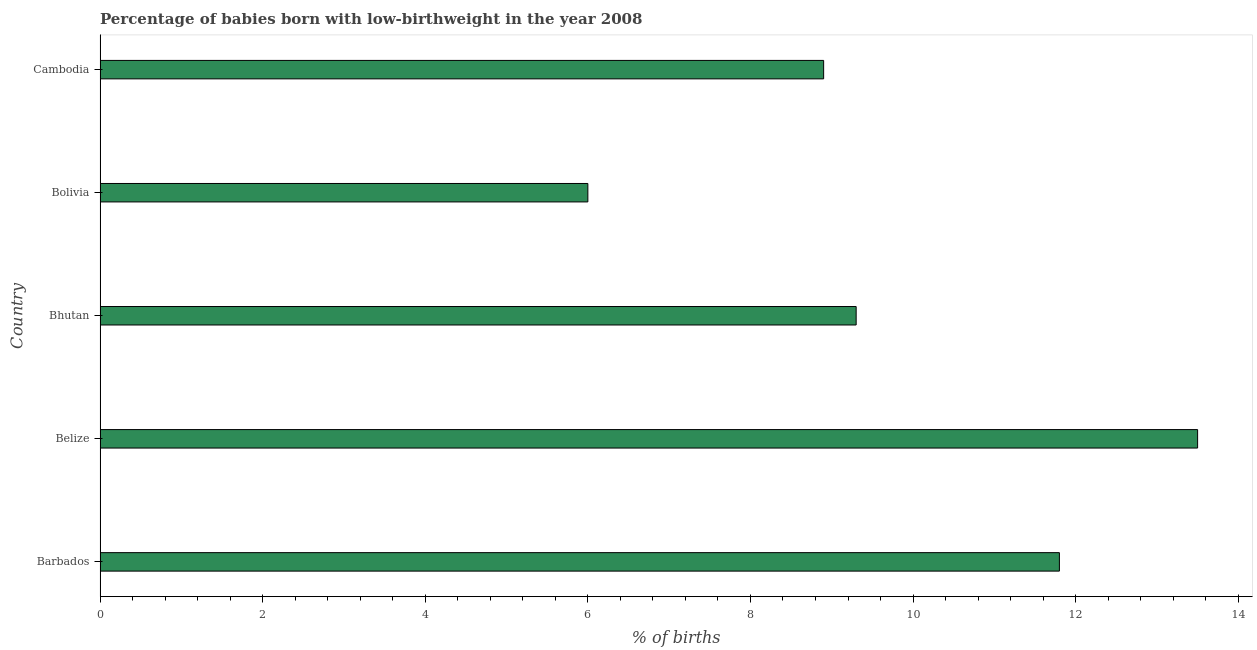Does the graph contain any zero values?
Offer a terse response. No. Does the graph contain grids?
Make the answer very short. No. What is the title of the graph?
Provide a short and direct response. Percentage of babies born with low-birthweight in the year 2008. What is the label or title of the X-axis?
Your answer should be compact. % of births. What is the label or title of the Y-axis?
Ensure brevity in your answer.  Country. What is the percentage of babies who were born with low-birthweight in Bolivia?
Make the answer very short. 6. Across all countries, what is the maximum percentage of babies who were born with low-birthweight?
Your answer should be compact. 13.5. Across all countries, what is the minimum percentage of babies who were born with low-birthweight?
Your response must be concise. 6. In which country was the percentage of babies who were born with low-birthweight maximum?
Provide a succinct answer. Belize. In which country was the percentage of babies who were born with low-birthweight minimum?
Your response must be concise. Bolivia. What is the sum of the percentage of babies who were born with low-birthweight?
Keep it short and to the point. 49.5. What is the average percentage of babies who were born with low-birthweight per country?
Ensure brevity in your answer.  9.9. What is the ratio of the percentage of babies who were born with low-birthweight in Barbados to that in Bhutan?
Offer a terse response. 1.27. Is the difference between the percentage of babies who were born with low-birthweight in Barbados and Belize greater than the difference between any two countries?
Make the answer very short. No. In how many countries, is the percentage of babies who were born with low-birthweight greater than the average percentage of babies who were born with low-birthweight taken over all countries?
Provide a succinct answer. 2. How many countries are there in the graph?
Your answer should be very brief. 5. Are the values on the major ticks of X-axis written in scientific E-notation?
Give a very brief answer. No. What is the % of births of Barbados?
Give a very brief answer. 11.8. What is the % of births in Belize?
Your answer should be very brief. 13.5. What is the difference between the % of births in Barbados and Belize?
Give a very brief answer. -1.7. What is the difference between the % of births in Barbados and Bhutan?
Give a very brief answer. 2.5. What is the difference between the % of births in Barbados and Bolivia?
Ensure brevity in your answer.  5.8. What is the difference between the % of births in Belize and Bhutan?
Your answer should be very brief. 4.2. What is the difference between the % of births in Belize and Bolivia?
Make the answer very short. 7.5. What is the difference between the % of births in Bhutan and Bolivia?
Offer a very short reply. 3.3. What is the difference between the % of births in Bolivia and Cambodia?
Your answer should be compact. -2.9. What is the ratio of the % of births in Barbados to that in Belize?
Give a very brief answer. 0.87. What is the ratio of the % of births in Barbados to that in Bhutan?
Give a very brief answer. 1.27. What is the ratio of the % of births in Barbados to that in Bolivia?
Make the answer very short. 1.97. What is the ratio of the % of births in Barbados to that in Cambodia?
Offer a very short reply. 1.33. What is the ratio of the % of births in Belize to that in Bhutan?
Your answer should be very brief. 1.45. What is the ratio of the % of births in Belize to that in Bolivia?
Keep it short and to the point. 2.25. What is the ratio of the % of births in Belize to that in Cambodia?
Make the answer very short. 1.52. What is the ratio of the % of births in Bhutan to that in Bolivia?
Offer a terse response. 1.55. What is the ratio of the % of births in Bhutan to that in Cambodia?
Ensure brevity in your answer.  1.04. What is the ratio of the % of births in Bolivia to that in Cambodia?
Your response must be concise. 0.67. 